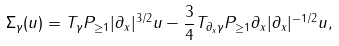Convert formula to latex. <formula><loc_0><loc_0><loc_500><loc_500>\Sigma _ { \gamma } ( u ) = T _ { \gamma } P _ { \geq 1 } | \partial _ { x } | ^ { 3 / 2 } u - \frac { 3 } { 4 } T _ { \partial _ { x } \gamma } P _ { \geq 1 } \partial _ { x } | \partial _ { x } | ^ { - 1 / 2 } u ,</formula> 